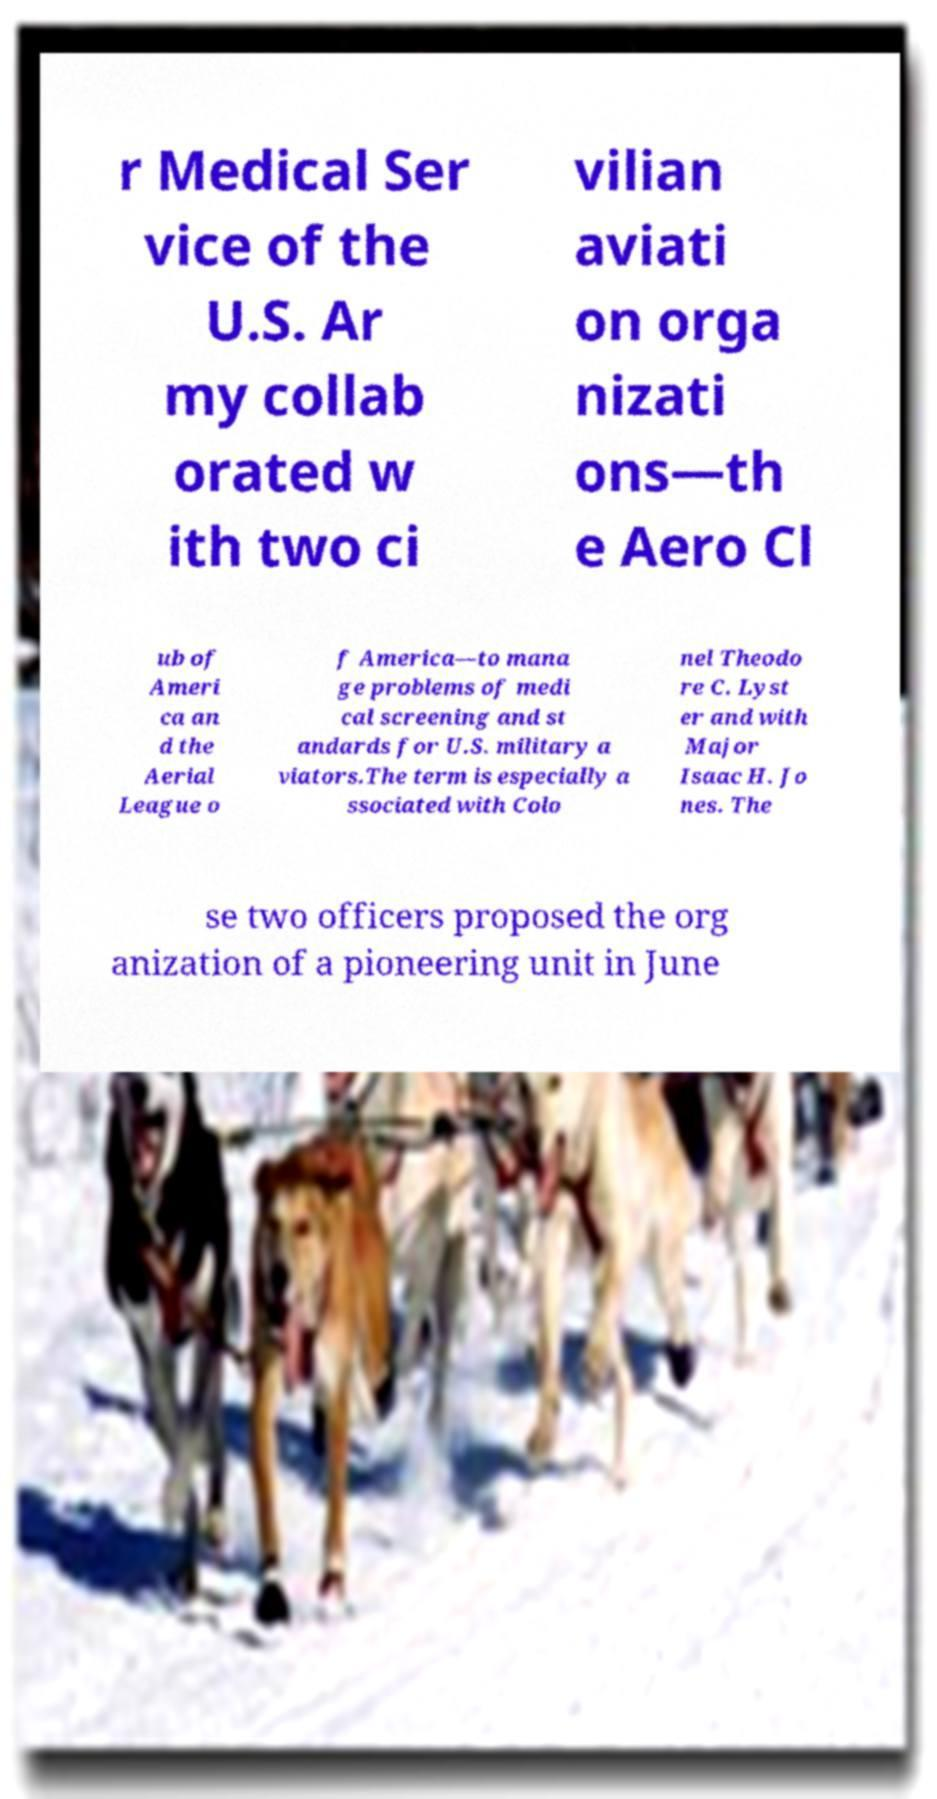Can you accurately transcribe the text from the provided image for me? r Medical Ser vice of the U.S. Ar my collab orated w ith two ci vilian aviati on orga nizati ons—th e Aero Cl ub of Ameri ca an d the Aerial League o f America—to mana ge problems of medi cal screening and st andards for U.S. military a viators.The term is especially a ssociated with Colo nel Theodo re C. Lyst er and with Major Isaac H. Jo nes. The se two officers proposed the org anization of a pioneering unit in June 